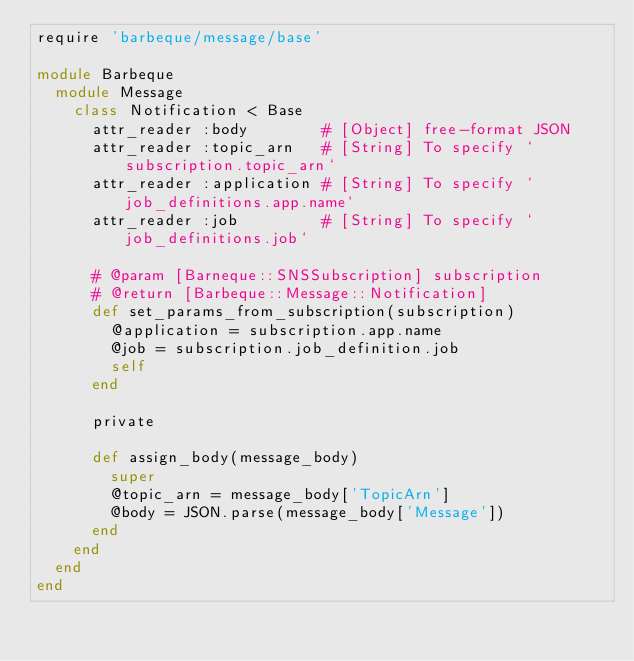<code> <loc_0><loc_0><loc_500><loc_500><_Ruby_>require 'barbeque/message/base'

module Barbeque
  module Message
    class Notification < Base
      attr_reader :body        # [Object] free-format JSON
      attr_reader :topic_arn   # [String] To specify `subscription.topic_arn`
      attr_reader :application # [String] To specify `job_definitions.app.name`
      attr_reader :job         # [String] To specify `job_definitions.job`

      # @param [Barneque::SNSSubscription] subscription
      # @return [Barbeque::Message::Notification]
      def set_params_from_subscription(subscription)
        @application = subscription.app.name
        @job = subscription.job_definition.job
        self
      end

      private

      def assign_body(message_body)
        super
        @topic_arn = message_body['TopicArn']
        @body = JSON.parse(message_body['Message'])
      end
    end
  end
end
</code> 